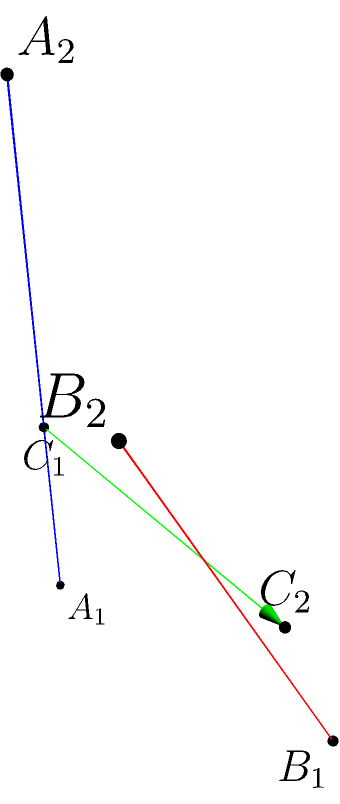Consider two skew lines in three-dimensional space:
Line 1: Passing through points $A_1(0,0,0)$ and $A_2(2,1,3)$
Line 2: Passing through points $B_1(1,2,0)$ and $B_2(3,2,2)$

Find the shortest distance between these two lines. Let's approach this step-by-step using the method we learned from Professor Groeneboom:

1) First, we need to find the direction vectors of the lines:
   $\vec{u} = A_2 - A_1 = (2-0, 1-0, 3-0) = (2, 1, 3)$
   $\vec{v} = B_2 - B_1 = (3-1, 2-2, 2-0) = (2, 0, 2)$

2) The shortest distance line will be perpendicular to both given lines. So, we can use the cross product:
   $\vec{n} = \vec{u} \times \vec{v} = (1\cdot2 - 3\cdot0, 3\cdot2 - 2\cdot2, 2\cdot0 - 1\cdot2) = (2, 2, -2)$

3) Now, we need a point on each line. We can use $A_1$ and $B_1$.

4) The vector equation of the shortest distance line is:
   $A_1 + t\vec{n} = B_1 + s\vec{v}$

5) This gives us three equations:
   $0 + 2t = 1 + 2s$
   $0 + 2t = 2 + 0s$
   $0 - 2t = 0 + 2s$

6) From the second equation: $t = 1$
   Substituting this into the first equation: $2 = 1 + 2s$, so $s = 0.5$

7) We can find points $C_1$ and $C_2$ on each line where the shortest distance line intersects:
   $C_1 = A_1 + t\vec{n} = (0,0,0) + 1(2,2,-2) = (2,2,-2)$
   $C_2 = B_1 + s\vec{v} = (1,2,0) + 0.5(2,0,2) = (2,2,1)$

8) The shortest distance is the magnitude of the vector $\vec{C_1C_2}$:
   $\vec{C_1C_2} = (2-2, 2-2, 1-(-2)) = (0, 0, 3)$
   Distance = $\sqrt{0^2 + 0^2 + 3^2} = 3$

Therefore, the shortest distance between the two skew lines is 3 units.
Answer: 3 units 